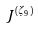Convert formula to latex. <formula><loc_0><loc_0><loc_500><loc_500>J ^ { ( \zeta _ { 9 } ) }</formula> 